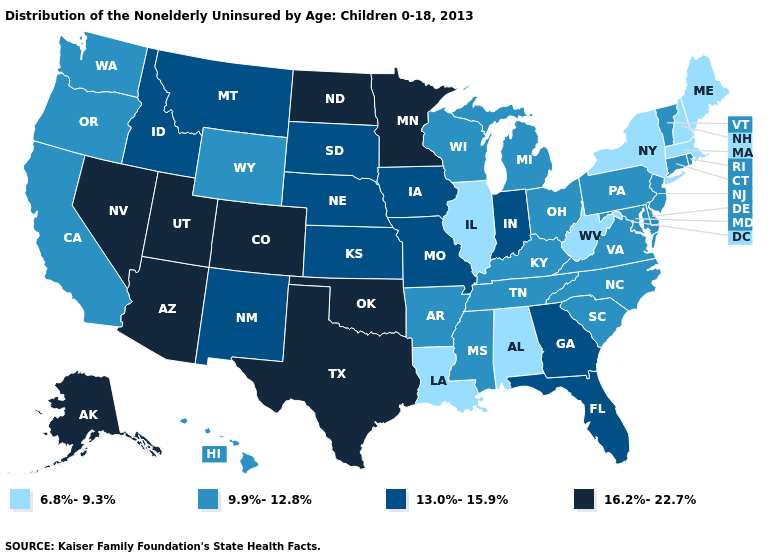Which states hav the highest value in the South?
Short answer required. Oklahoma, Texas. What is the value of California?
Keep it brief. 9.9%-12.8%. What is the value of Nebraska?
Give a very brief answer. 13.0%-15.9%. What is the value of New Mexico?
Keep it brief. 13.0%-15.9%. Name the states that have a value in the range 13.0%-15.9%?
Keep it brief. Florida, Georgia, Idaho, Indiana, Iowa, Kansas, Missouri, Montana, Nebraska, New Mexico, South Dakota. Does Vermont have a higher value than Alaska?
Quick response, please. No. Among the states that border Arkansas , which have the highest value?
Be succinct. Oklahoma, Texas. Which states hav the highest value in the South?
Give a very brief answer. Oklahoma, Texas. Among the states that border North Carolina , does South Carolina have the highest value?
Answer briefly. No. Does Rhode Island have a higher value than Iowa?
Give a very brief answer. No. Does the map have missing data?
Concise answer only. No. Among the states that border Idaho , which have the highest value?
Short answer required. Nevada, Utah. What is the value of Illinois?
Quick response, please. 6.8%-9.3%. Name the states that have a value in the range 6.8%-9.3%?
Keep it brief. Alabama, Illinois, Louisiana, Maine, Massachusetts, New Hampshire, New York, West Virginia. Name the states that have a value in the range 6.8%-9.3%?
Write a very short answer. Alabama, Illinois, Louisiana, Maine, Massachusetts, New Hampshire, New York, West Virginia. 